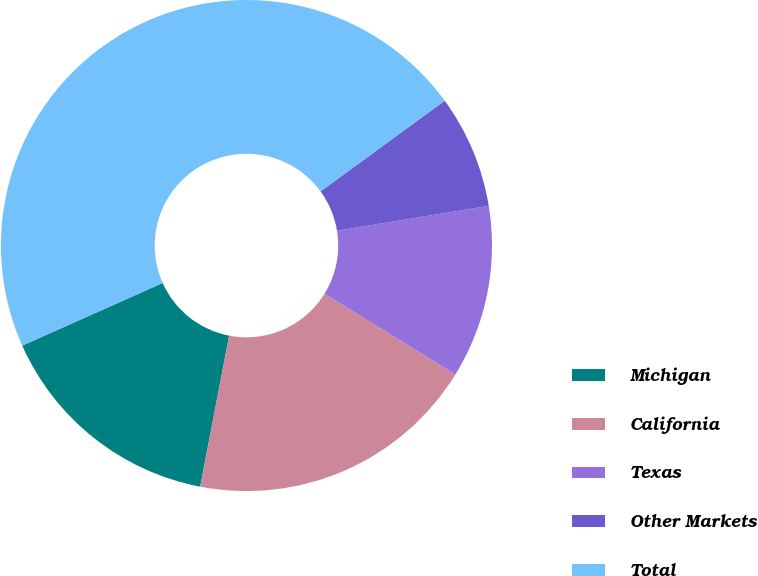Convert chart. <chart><loc_0><loc_0><loc_500><loc_500><pie_chart><fcel>Michigan<fcel>California<fcel>Texas<fcel>Other Markets<fcel>Total<nl><fcel>15.3%<fcel>19.22%<fcel>11.38%<fcel>7.46%<fcel>46.64%<nl></chart> 